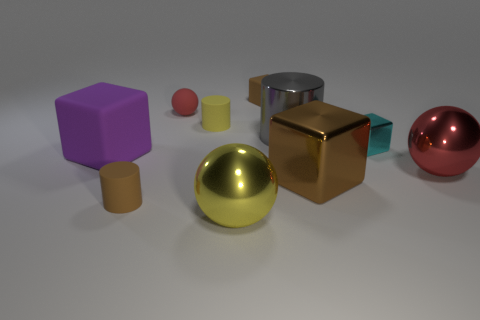Subtract all tiny brown rubber cubes. How many cubes are left? 3 Subtract 2 spheres. How many spheres are left? 1 Subtract all red spheres. How many spheres are left? 1 Subtract all spheres. How many objects are left? 7 Subtract all cyan cylinders. Subtract all purple blocks. How many cylinders are left? 3 Subtract all green cylinders. How many cyan spheres are left? 0 Subtract all large cyan metallic things. Subtract all large matte objects. How many objects are left? 9 Add 8 small brown cylinders. How many small brown cylinders are left? 9 Add 2 cyan metal spheres. How many cyan metal spheres exist? 2 Subtract 0 green cubes. How many objects are left? 10 